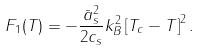<formula> <loc_0><loc_0><loc_500><loc_500>F _ { 1 } ( T ) = - \frac { \bar { a } _ { s } ^ { 2 } } { 2 c _ { s } } k _ { B } ^ { 2 } \left [ T _ { c } - T \right ] ^ { 2 } .</formula> 